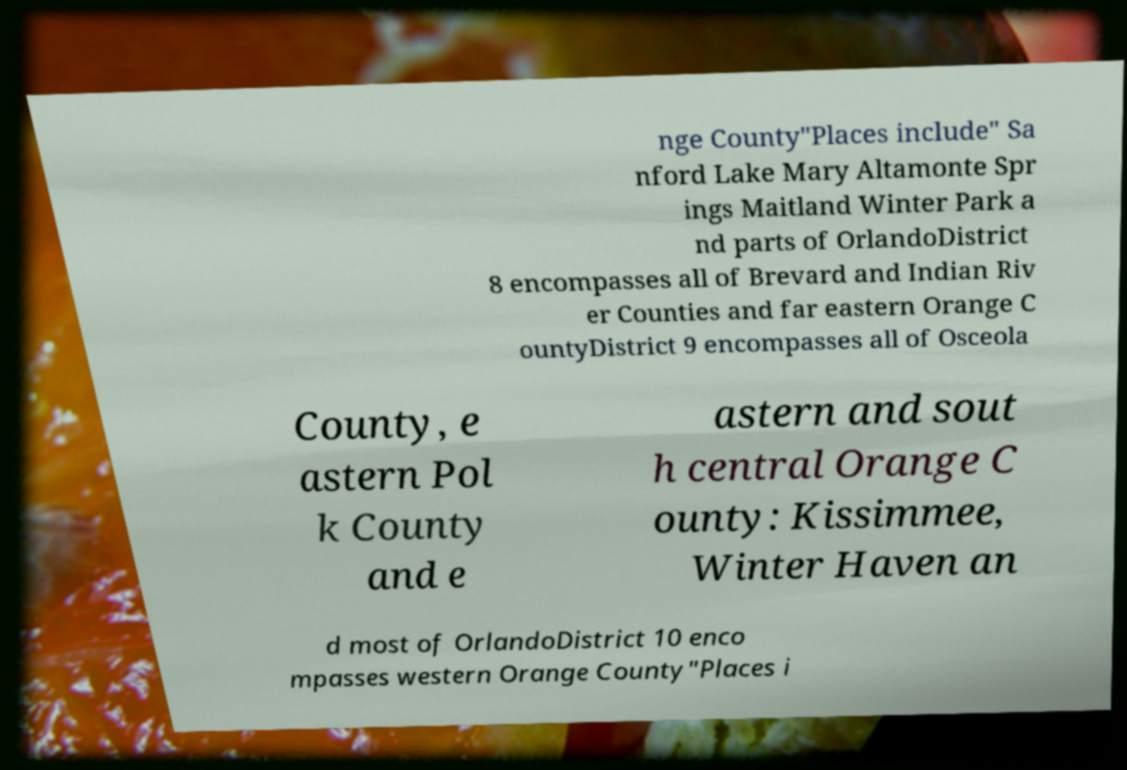There's text embedded in this image that I need extracted. Can you transcribe it verbatim? nge County"Places include" Sa nford Lake Mary Altamonte Spr ings Maitland Winter Park a nd parts of OrlandoDistrict 8 encompasses all of Brevard and Indian Riv er Counties and far eastern Orange C ountyDistrict 9 encompasses all of Osceola County, e astern Pol k County and e astern and sout h central Orange C ounty: Kissimmee, Winter Haven an d most of OrlandoDistrict 10 enco mpasses western Orange County"Places i 